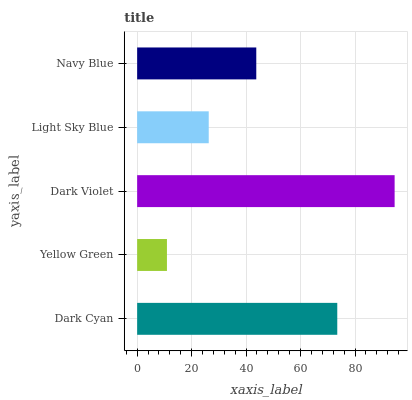Is Yellow Green the minimum?
Answer yes or no. Yes. Is Dark Violet the maximum?
Answer yes or no. Yes. Is Dark Violet the minimum?
Answer yes or no. No. Is Yellow Green the maximum?
Answer yes or no. No. Is Dark Violet greater than Yellow Green?
Answer yes or no. Yes. Is Yellow Green less than Dark Violet?
Answer yes or no. Yes. Is Yellow Green greater than Dark Violet?
Answer yes or no. No. Is Dark Violet less than Yellow Green?
Answer yes or no. No. Is Navy Blue the high median?
Answer yes or no. Yes. Is Navy Blue the low median?
Answer yes or no. Yes. Is Light Sky Blue the high median?
Answer yes or no. No. Is Yellow Green the low median?
Answer yes or no. No. 